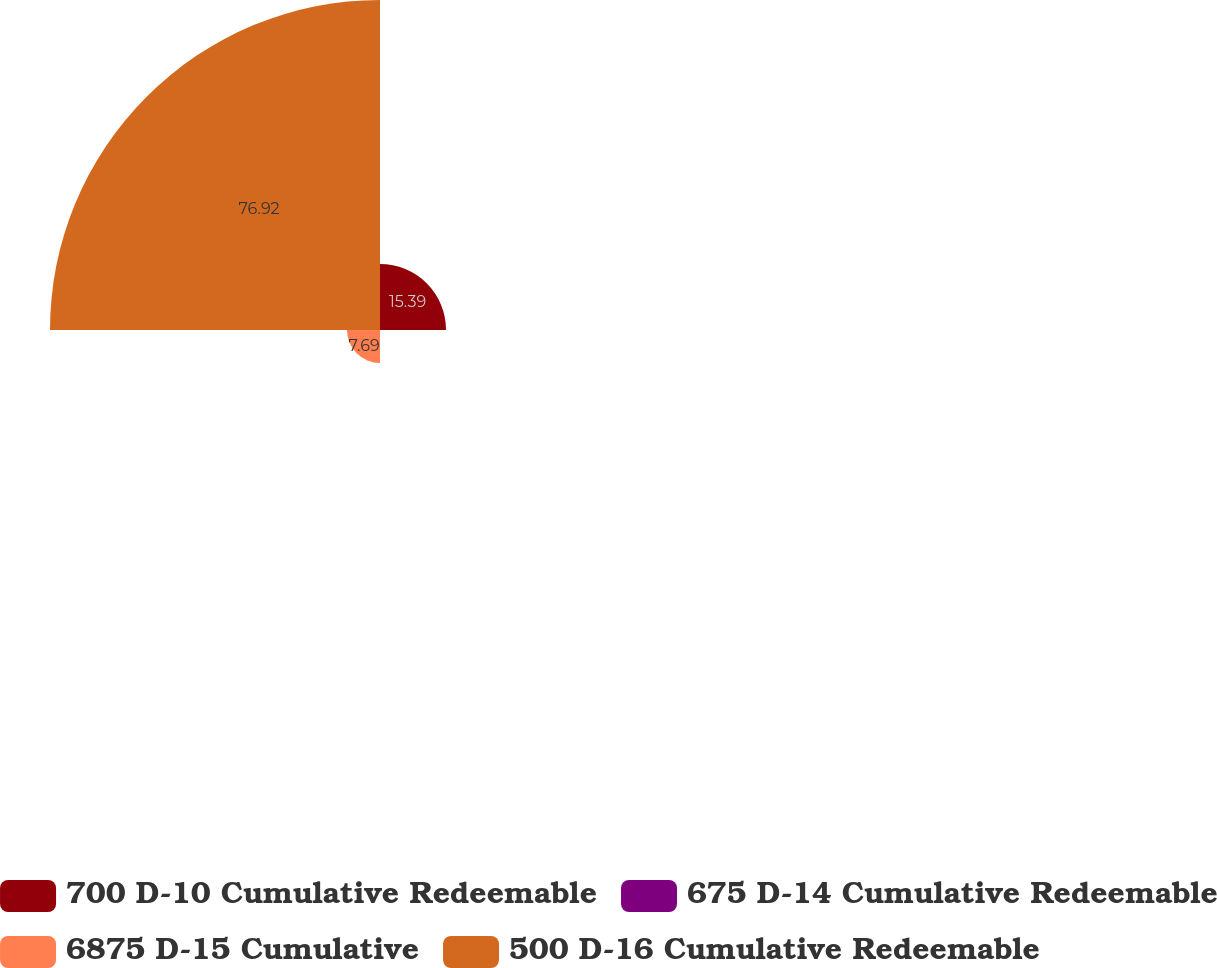Convert chart to OTSL. <chart><loc_0><loc_0><loc_500><loc_500><pie_chart><fcel>700 D-10 Cumulative Redeemable<fcel>675 D-14 Cumulative Redeemable<fcel>6875 D-15 Cumulative<fcel>500 D-16 Cumulative Redeemable<nl><fcel>15.39%<fcel>0.0%<fcel>7.69%<fcel>76.92%<nl></chart> 